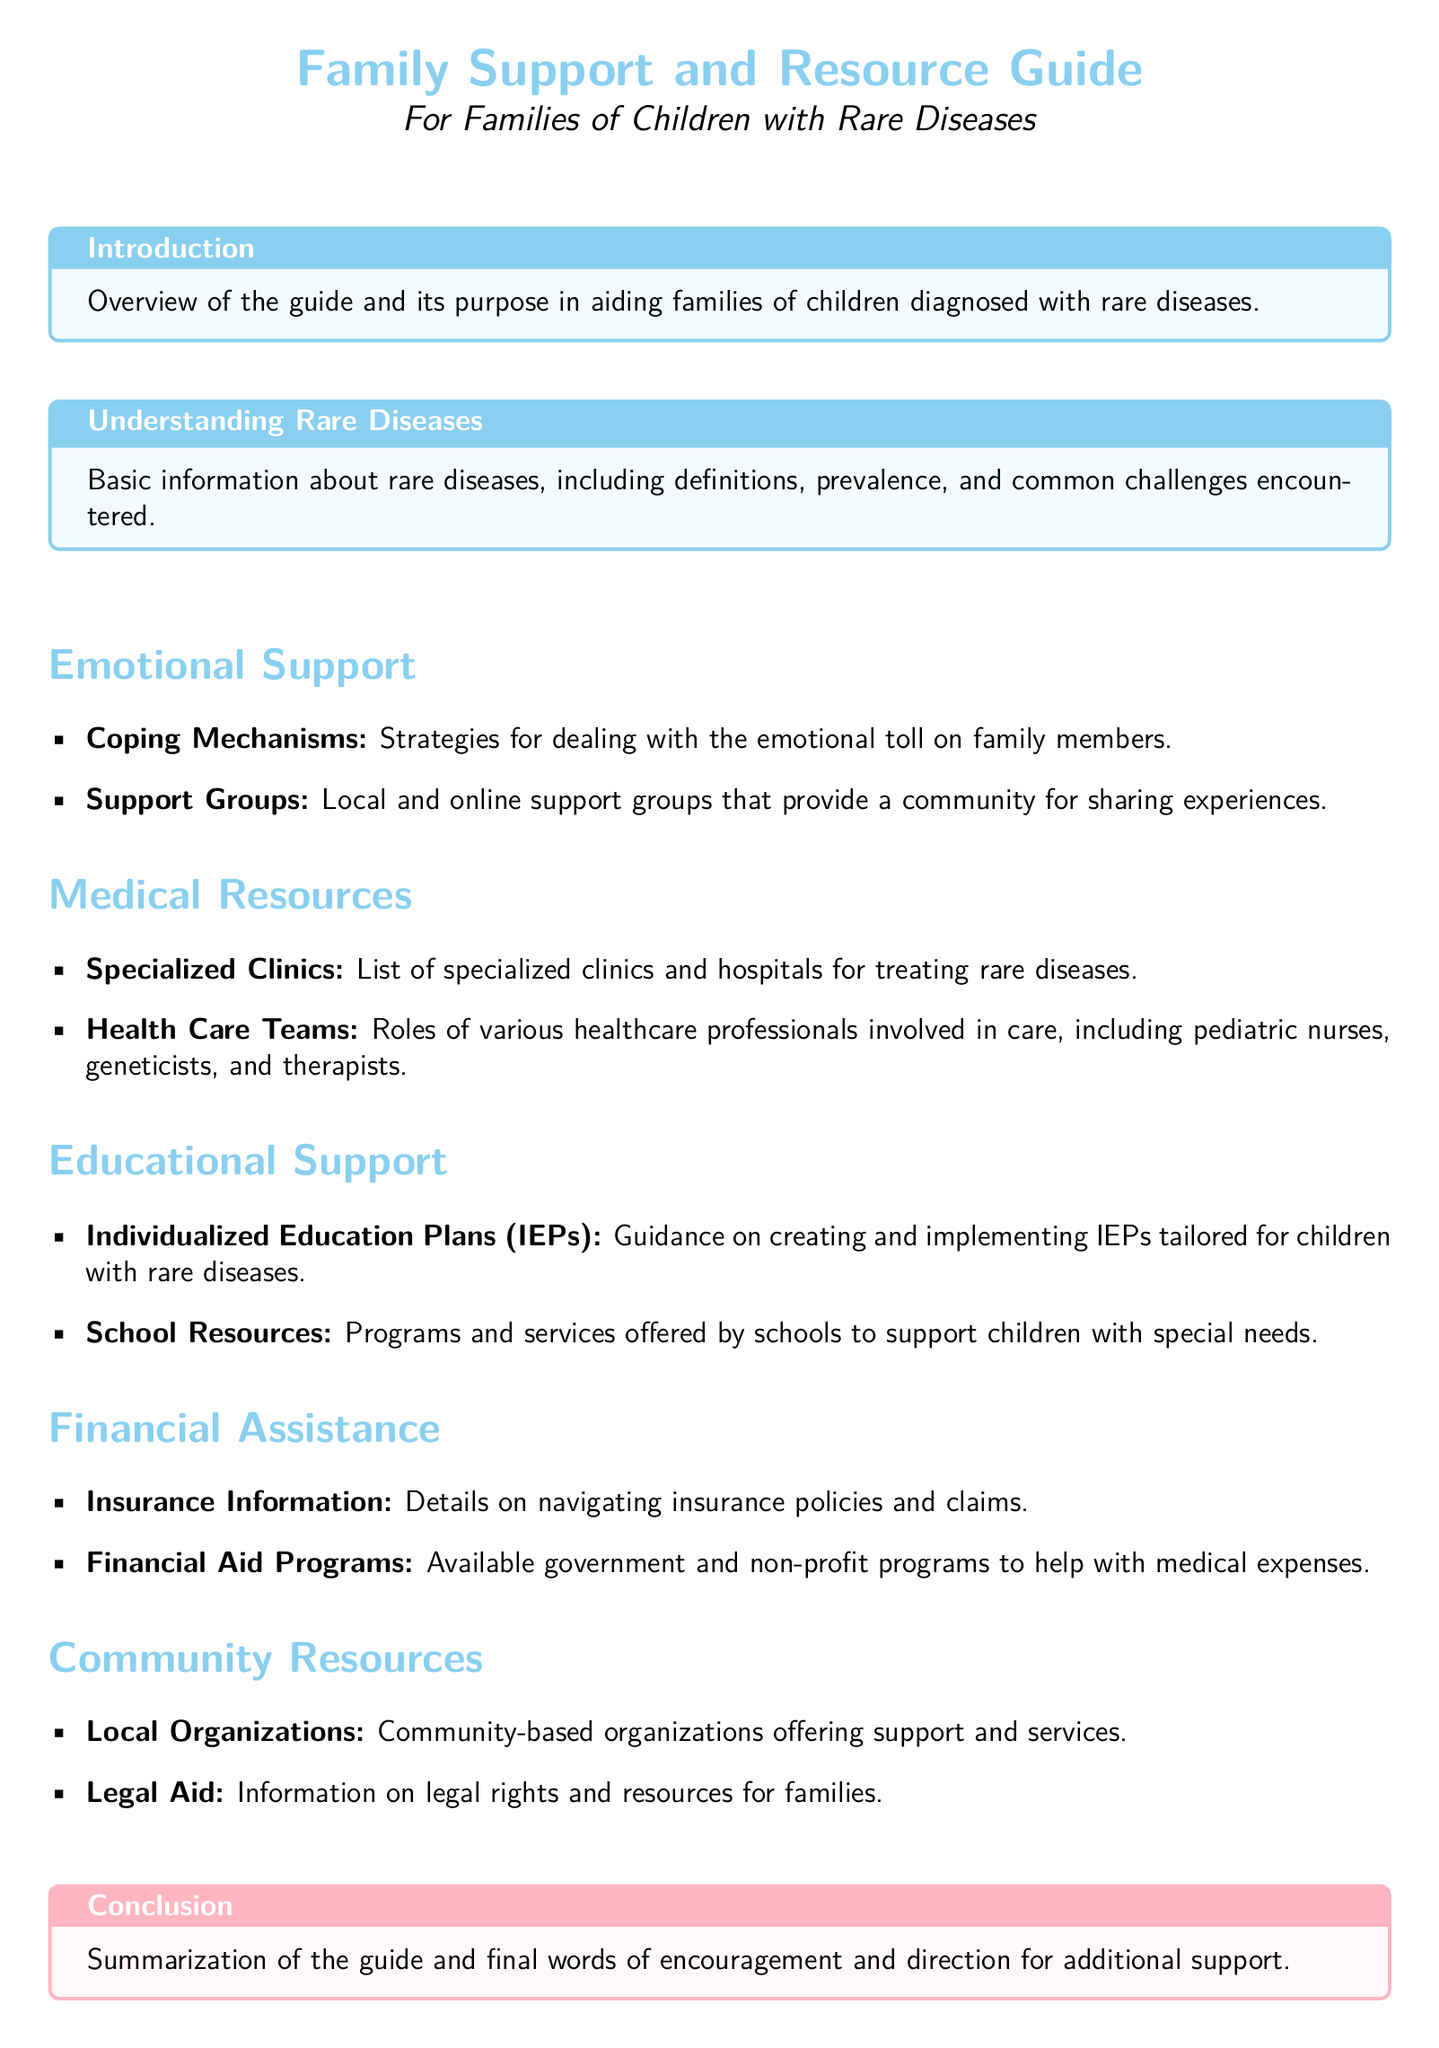What is the primary purpose of the guide? The guide aims to provide information, emotional support, and resources for families of children with rare diseases.
Answer: To provide information, emotional support, and resources for families of children with rare diseases What is one type of coping mechanism mentioned? The document includes strategies for dealing with the emotional toll on family members as a coping mechanism.
Answer: Strategies for dealing with emotional toll How many sections are dedicated to support types in the document? The document lists five distinct sections: Emotional Support, Medical Resources, Educational Support, Financial Assistance, and Community Resources.
Answer: Five What does IEP stand for? The document states that IEP refers to Individualized Education Plans, which are tailored for children with rare diseases.
Answer: Individualized Education Plans What kind of assistance is available for medical expenses? The document mentions financial aid programs that help with medical expenses.
Answer: Financial aid programs Which healthcare professionals are involved in care? The document lists pediatric nurses, geneticists, and therapists as part of the healthcare teams involved in care.
Answer: Pediatric nurses, geneticists, and therapists What is included in the conclusion section? The conclusion provides a summarization of the guide and final words of encouragement and direction for additional support.
Answer: Summarization and final words of encouragement What type of resources do local organizations provide? Local organizations are described as offering support and services for families.
Answer: Support and services What is one resource mentioned for navigating insurance? The document specifies that there is insurance information provided to help families navigate insurance policies and claims.
Answer: Insurance information 